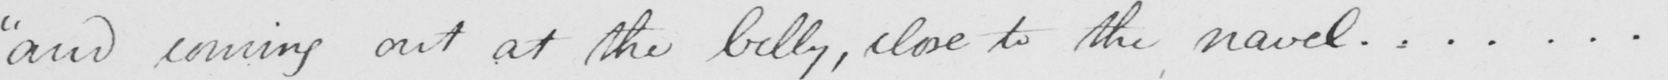What does this handwritten line say? " and coming out at the belly , close to the navel...... . 